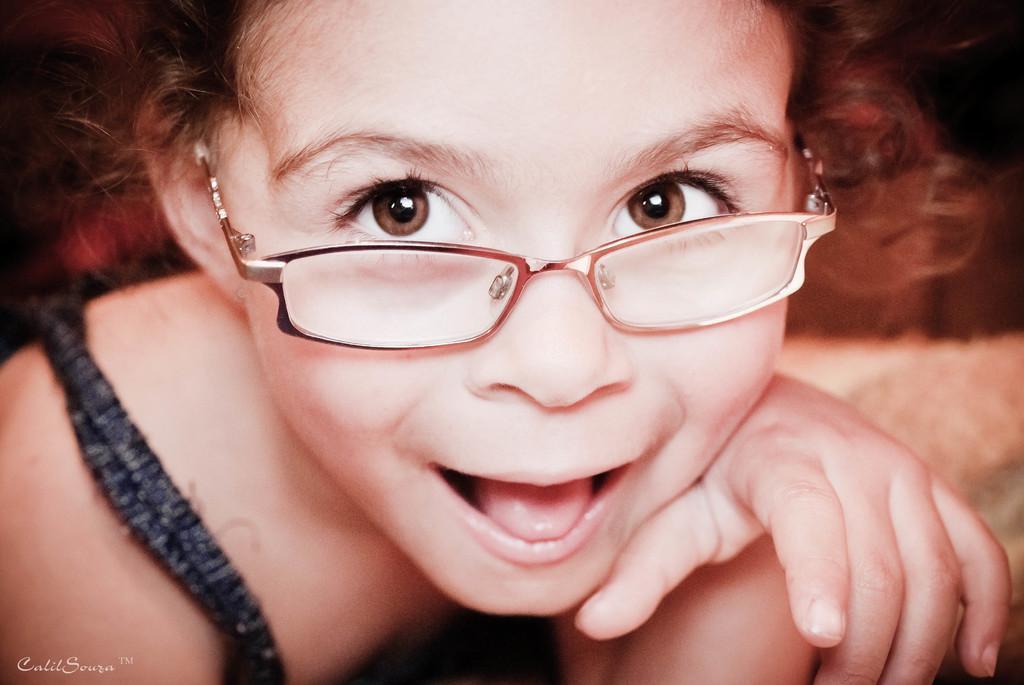Can you describe this image briefly? In this picture I can observe a girl. She is wearing spectacles. The girl is smiling. On the bottom left side I can observe watermark. The background is blurred. 